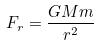Convert formula to latex. <formula><loc_0><loc_0><loc_500><loc_500>F _ { r } = \frac { G M m } { r ^ { 2 } }</formula> 